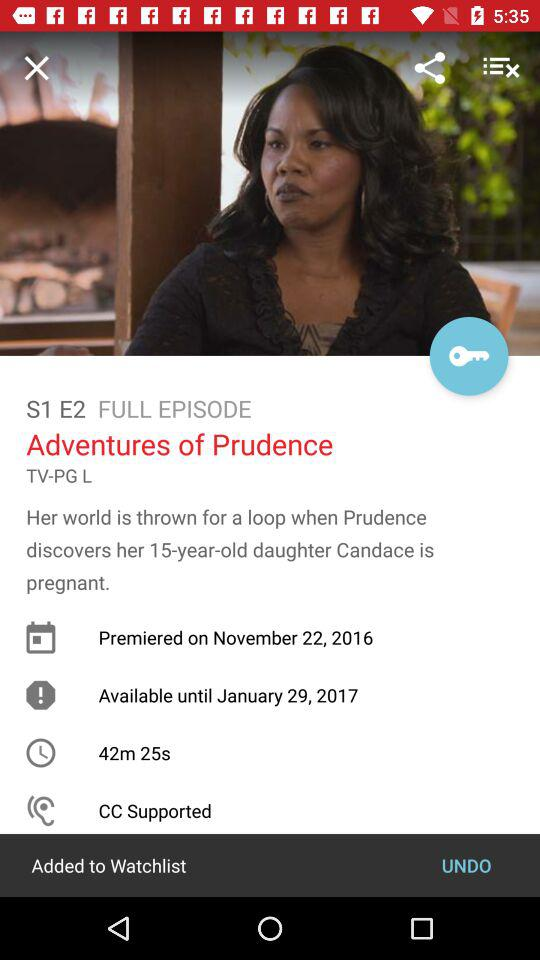Which season is this? This is season 1. 